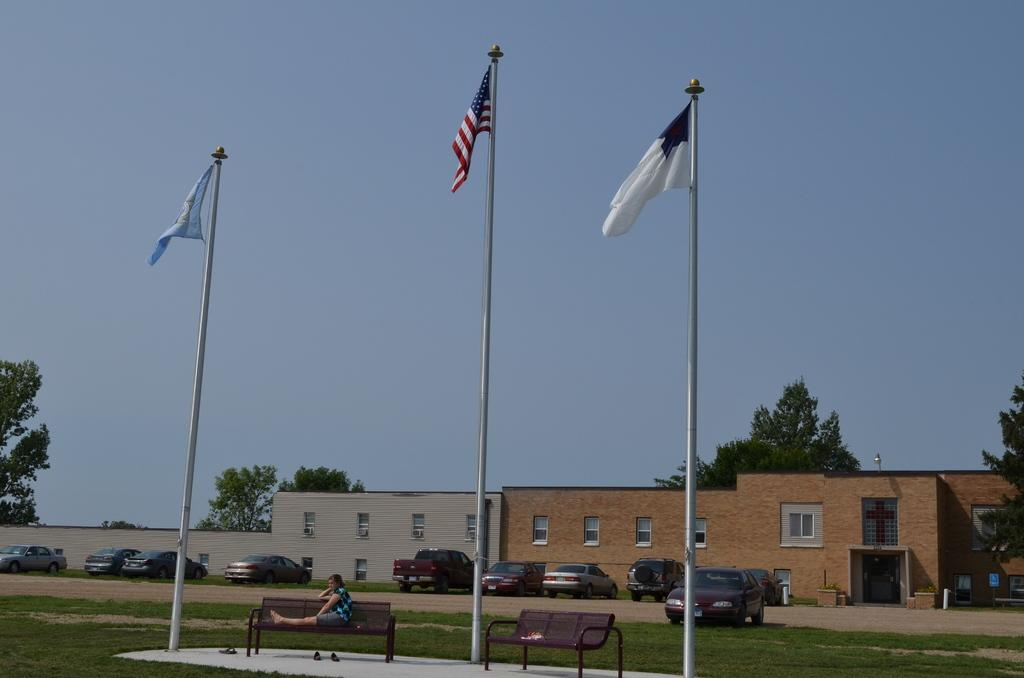What is the person in the image doing? There is a person sitting on a bench in the image. What can be seen in the image besides the person on the bench? There are flags, vehicles, buildings, trees, and the sky visible in the image. Can you describe the background of the image? The background of the image includes buildings, trees, and the sky. What type of vest is the person wearing in the image? There is no vest visible in the image; the person is simply sitting on a bench. How many feet can be seen in the image? The image does not show any feet; it only shows a person sitting on a bench. 